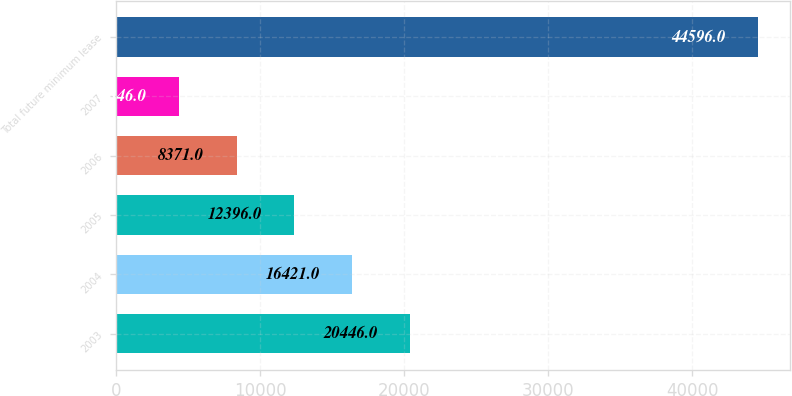Convert chart to OTSL. <chart><loc_0><loc_0><loc_500><loc_500><bar_chart><fcel>2003<fcel>2004<fcel>2005<fcel>2006<fcel>2007<fcel>Total future minimum lease<nl><fcel>20446<fcel>16421<fcel>12396<fcel>8371<fcel>4346<fcel>44596<nl></chart> 